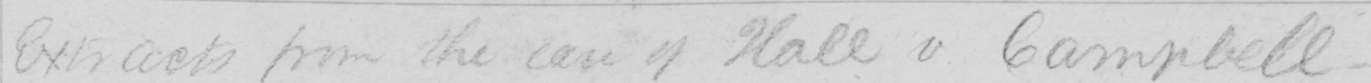Can you tell me what this handwritten text says? Extracts from the case of Hall v Campbell 